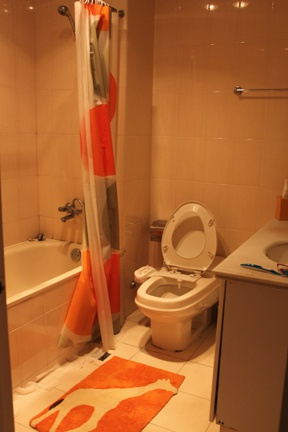Describe the objects in this image and their specific colors. I can see toilet in brown, orange, and maroon tones, sink in brown, tan, and maroon tones, and toothbrush in brown, black, and maroon tones in this image. 